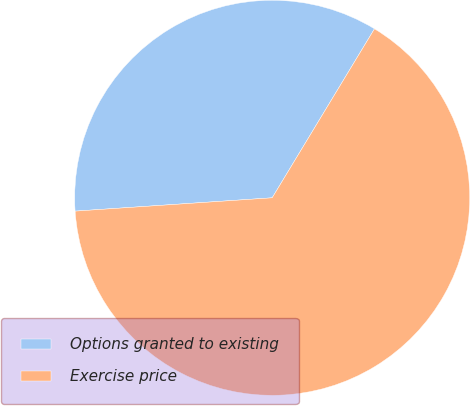Convert chart. <chart><loc_0><loc_0><loc_500><loc_500><pie_chart><fcel>Options granted to existing<fcel>Exercise price<nl><fcel>34.74%<fcel>65.26%<nl></chart> 